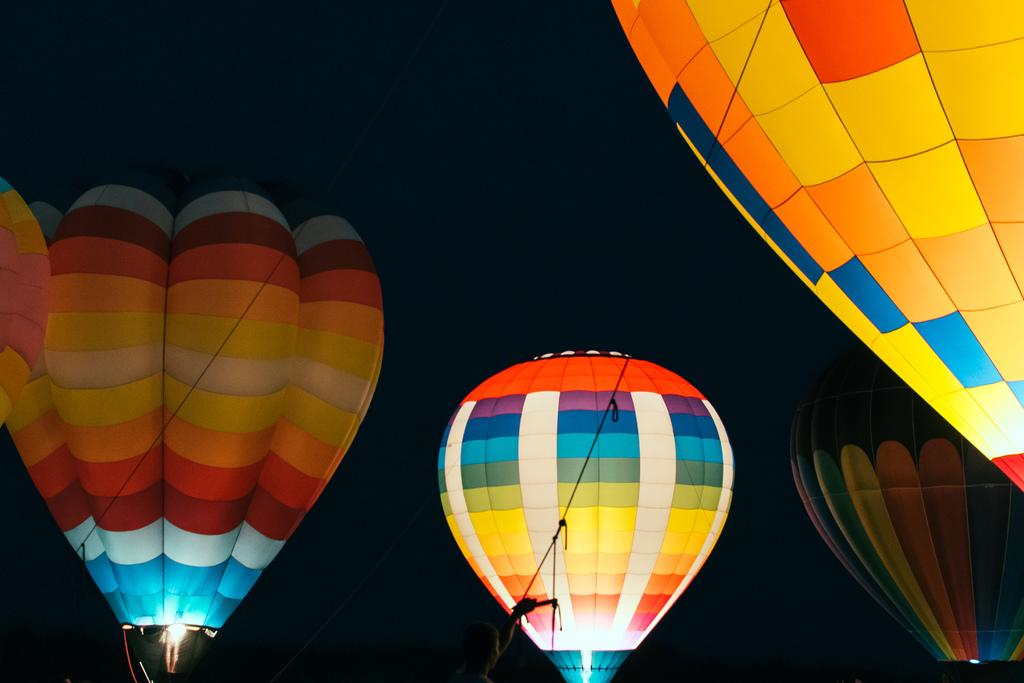How many hot air balloons are in the image? There are 4 hot air balloons in the image. What can be observed about the appearance of the hot air balloons? The hot air balloons are of different colors. What object can be seen connecting the hot air balloons to the ground? There is a rope visible in the image. What type of illumination is present in the image? There is a light in the image. How would you describe the overall lighting condition in the image? The background of the image is dark. Where can the office be found in the image? There is no office present in the image. --- Facts: 1. There is a person in the image. 2. The person is wearing a hat. 3. The person is holding a book. 4. There is a table in the image. 5. The table has a vase with flowers on it. Absurd Topics: unicorn, spaceship, alien Conversation: What is the main subject in the image? There is a person in the image. What can be observed about the person's attire? The person is wearing a hat. What object is the person holding? The person is holding a book. What is present on the table in the image? There is a vase with flowers on it. Reasoning: Let's think step by step in order to ${produce the conversation}. We start by identifying the main subject of the image, which is the person. Next, we describe specific features of the person, such as the hat. Then, we observe the actions of the person, noting that they are holding a book. Finally, we describe the objects present on the table, which is a vase with flowers on it. Absurd Question/Answer: How many unicorns can be seen grazing in the image? There are no unicorns present in the image. 